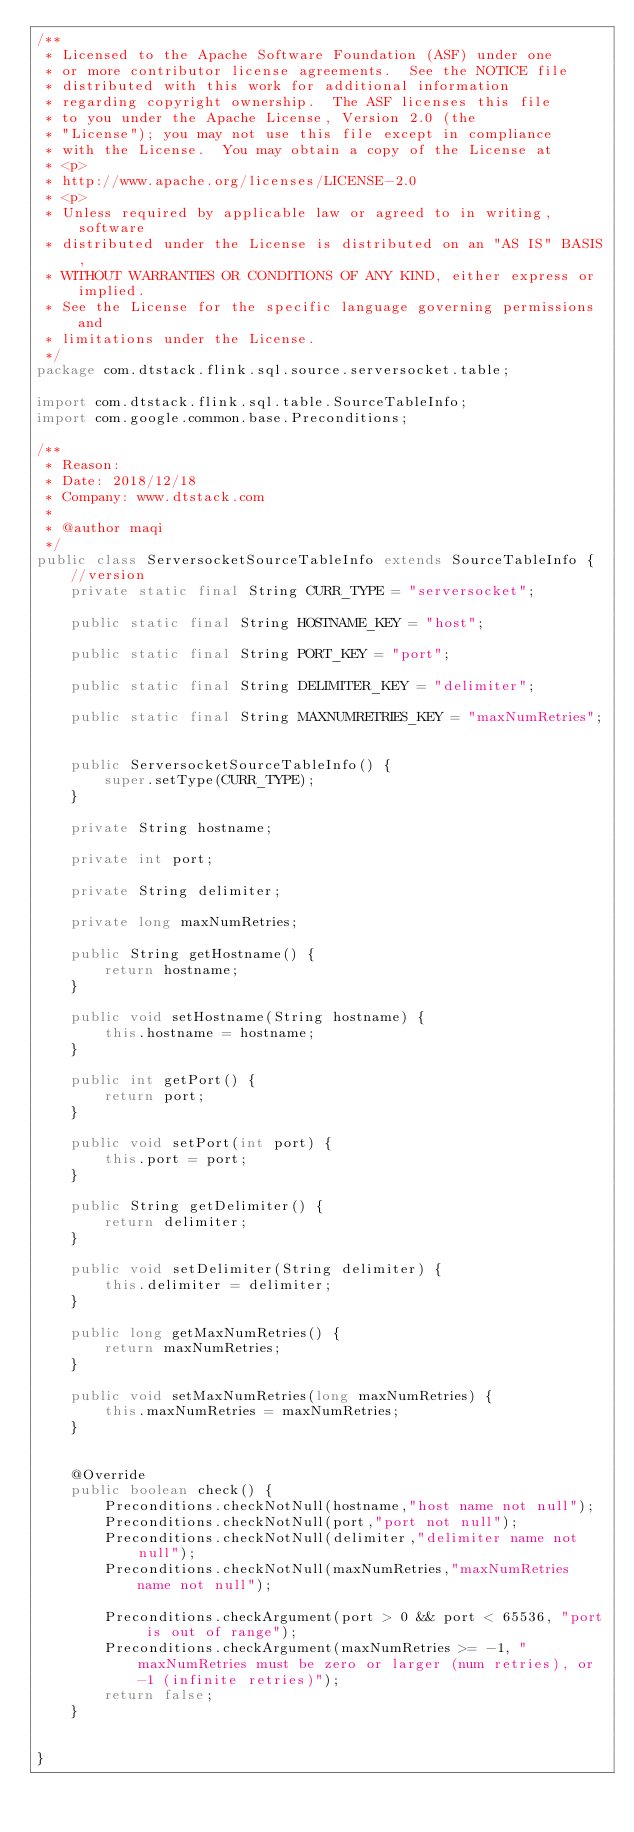<code> <loc_0><loc_0><loc_500><loc_500><_Java_>/**
 * Licensed to the Apache Software Foundation (ASF) under one
 * or more contributor license agreements.  See the NOTICE file
 * distributed with this work for additional information
 * regarding copyright ownership.  The ASF licenses this file
 * to you under the Apache License, Version 2.0 (the
 * "License"); you may not use this file except in compliance
 * with the License.  You may obtain a copy of the License at
 * <p>
 * http://www.apache.org/licenses/LICENSE-2.0
 * <p>
 * Unless required by applicable law or agreed to in writing, software
 * distributed under the License is distributed on an "AS IS" BASIS,
 * WITHOUT WARRANTIES OR CONDITIONS OF ANY KIND, either express or implied.
 * See the License for the specific language governing permissions and
 * limitations under the License.
 */
package com.dtstack.flink.sql.source.serversocket.table;

import com.dtstack.flink.sql.table.SourceTableInfo;
import com.google.common.base.Preconditions;

/**
 * Reason:
 * Date: 2018/12/18
 * Company: www.dtstack.com
 *
 * @author maqi
 */
public class ServersocketSourceTableInfo extends SourceTableInfo {
	//version
	private static final String CURR_TYPE = "serversocket";

	public static final String HOSTNAME_KEY = "host";

	public static final String PORT_KEY = "port";

	public static final String DELIMITER_KEY = "delimiter";

	public static final String MAXNUMRETRIES_KEY = "maxNumRetries";


	public ServersocketSourceTableInfo() {
		super.setType(CURR_TYPE);
	}

	private String hostname;

	private int port;

	private String delimiter;

	private long maxNumRetries;

	public String getHostname() {
		return hostname;
	}

	public void setHostname(String hostname) {
		this.hostname = hostname;
	}

	public int getPort() {
		return port;
	}

	public void setPort(int port) {
		this.port = port;
	}

	public String getDelimiter() {
		return delimiter;
	}

	public void setDelimiter(String delimiter) {
		this.delimiter = delimiter;
	}

	public long getMaxNumRetries() {
		return maxNumRetries;
	}

	public void setMaxNumRetries(long maxNumRetries) {
		this.maxNumRetries = maxNumRetries;
	}


	@Override
	public boolean check() {
		Preconditions.checkNotNull(hostname,"host name not null");
		Preconditions.checkNotNull(port,"port not null");
		Preconditions.checkNotNull(delimiter,"delimiter name not null");
		Preconditions.checkNotNull(maxNumRetries,"maxNumRetries name not null");

		Preconditions.checkArgument(port > 0 && port < 65536, "port is out of range");
		Preconditions.checkArgument(maxNumRetries >= -1, "maxNumRetries must be zero or larger (num retries), or -1 (infinite retries)");
		return false;
	}


}
</code> 